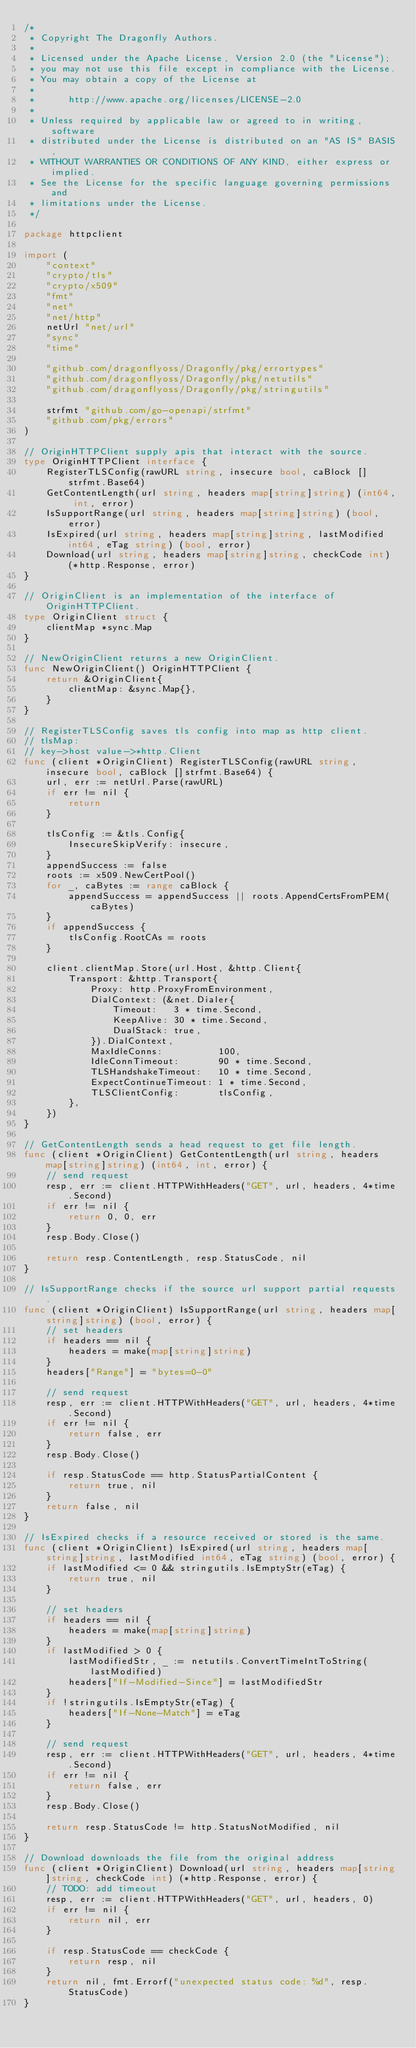Convert code to text. <code><loc_0><loc_0><loc_500><loc_500><_Go_>/*
 * Copyright The Dragonfly Authors.
 *
 * Licensed under the Apache License, Version 2.0 (the "License");
 * you may not use this file except in compliance with the License.
 * You may obtain a copy of the License at
 *
 *      http://www.apache.org/licenses/LICENSE-2.0
 *
 * Unless required by applicable law or agreed to in writing, software
 * distributed under the License is distributed on an "AS IS" BASIS,
 * WITHOUT WARRANTIES OR CONDITIONS OF ANY KIND, either express or implied.
 * See the License for the specific language governing permissions and
 * limitations under the License.
 */

package httpclient

import (
	"context"
	"crypto/tls"
	"crypto/x509"
	"fmt"
	"net"
	"net/http"
	netUrl "net/url"
	"sync"
	"time"

	"github.com/dragonflyoss/Dragonfly/pkg/errortypes"
	"github.com/dragonflyoss/Dragonfly/pkg/netutils"
	"github.com/dragonflyoss/Dragonfly/pkg/stringutils"

	strfmt "github.com/go-openapi/strfmt"
	"github.com/pkg/errors"
)

// OriginHTTPClient supply apis that interact with the source.
type OriginHTTPClient interface {
	RegisterTLSConfig(rawURL string, insecure bool, caBlock []strfmt.Base64)
	GetContentLength(url string, headers map[string]string) (int64, int, error)
	IsSupportRange(url string, headers map[string]string) (bool, error)
	IsExpired(url string, headers map[string]string, lastModified int64, eTag string) (bool, error)
	Download(url string, headers map[string]string, checkCode int) (*http.Response, error)
}

// OriginClient is an implementation of the interface of OriginHTTPClient.
type OriginClient struct {
	clientMap *sync.Map
}

// NewOriginClient returns a new OriginClient.
func NewOriginClient() OriginHTTPClient {
	return &OriginClient{
		clientMap: &sync.Map{},
	}
}

// RegisterTLSConfig saves tls config into map as http client.
// tlsMap:
// key->host value->*http.Client
func (client *OriginClient) RegisterTLSConfig(rawURL string, insecure bool, caBlock []strfmt.Base64) {
	url, err := netUrl.Parse(rawURL)
	if err != nil {
		return
	}

	tlsConfig := &tls.Config{
		InsecureSkipVerify: insecure,
	}
	appendSuccess := false
	roots := x509.NewCertPool()
	for _, caBytes := range caBlock {
		appendSuccess = appendSuccess || roots.AppendCertsFromPEM(caBytes)
	}
	if appendSuccess {
		tlsConfig.RootCAs = roots
	}

	client.clientMap.Store(url.Host, &http.Client{
		Transport: &http.Transport{
			Proxy: http.ProxyFromEnvironment,
			DialContext: (&net.Dialer{
				Timeout:   3 * time.Second,
				KeepAlive: 30 * time.Second,
				DualStack: true,
			}).DialContext,
			MaxIdleConns:          100,
			IdleConnTimeout:       90 * time.Second,
			TLSHandshakeTimeout:   10 * time.Second,
			ExpectContinueTimeout: 1 * time.Second,
			TLSClientConfig:       tlsConfig,
		},
	})
}

// GetContentLength sends a head request to get file length.
func (client *OriginClient) GetContentLength(url string, headers map[string]string) (int64, int, error) {
	// send request
	resp, err := client.HTTPWithHeaders("GET", url, headers, 4*time.Second)
	if err != nil {
		return 0, 0, err
	}
	resp.Body.Close()

	return resp.ContentLength, resp.StatusCode, nil
}

// IsSupportRange checks if the source url support partial requests.
func (client *OriginClient) IsSupportRange(url string, headers map[string]string) (bool, error) {
	// set headers
	if headers == nil {
		headers = make(map[string]string)
	}
	headers["Range"] = "bytes=0-0"

	// send request
	resp, err := client.HTTPWithHeaders("GET", url, headers, 4*time.Second)
	if err != nil {
		return false, err
	}
	resp.Body.Close()

	if resp.StatusCode == http.StatusPartialContent {
		return true, nil
	}
	return false, nil
}

// IsExpired checks if a resource received or stored is the same.
func (client *OriginClient) IsExpired(url string, headers map[string]string, lastModified int64, eTag string) (bool, error) {
	if lastModified <= 0 && stringutils.IsEmptyStr(eTag) {
		return true, nil
	}

	// set headers
	if headers == nil {
		headers = make(map[string]string)
	}
	if lastModified > 0 {
		lastModifiedStr, _ := netutils.ConvertTimeIntToString(lastModified)
		headers["If-Modified-Since"] = lastModifiedStr
	}
	if !stringutils.IsEmptyStr(eTag) {
		headers["If-None-Match"] = eTag
	}

	// send request
	resp, err := client.HTTPWithHeaders("GET", url, headers, 4*time.Second)
	if err != nil {
		return false, err
	}
	resp.Body.Close()

	return resp.StatusCode != http.StatusNotModified, nil
}

// Download downloads the file from the original address
func (client *OriginClient) Download(url string, headers map[string]string, checkCode int) (*http.Response, error) {
	// TODO: add timeout
	resp, err := client.HTTPWithHeaders("GET", url, headers, 0)
	if err != nil {
		return nil, err
	}

	if resp.StatusCode == checkCode {
		return resp, nil
	}
	return nil, fmt.Errorf("unexpected status code: %d", resp.StatusCode)
}
</code> 